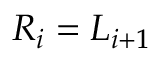Convert formula to latex. <formula><loc_0><loc_0><loc_500><loc_500>R _ { i } = L _ { i + 1 }</formula> 